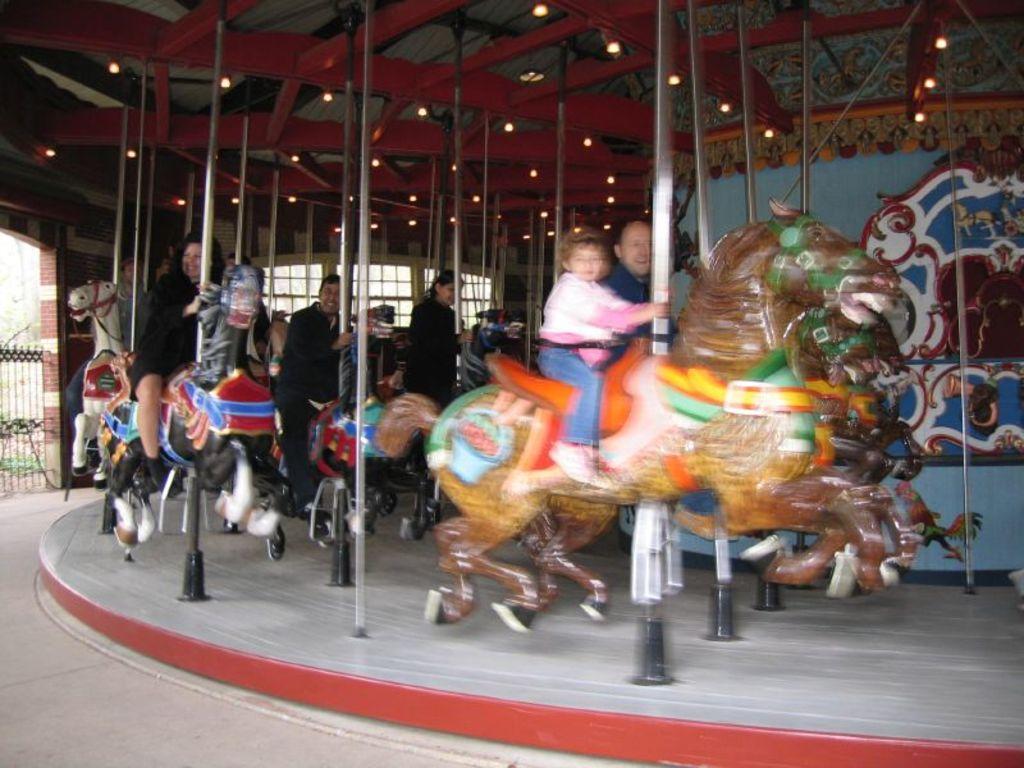Could you give a brief overview of what you see in this image? In this picture we can see the group of people and the carousel, we can see the metal rods, sculptures of animals and we can see the lights, windows and some other objects. 